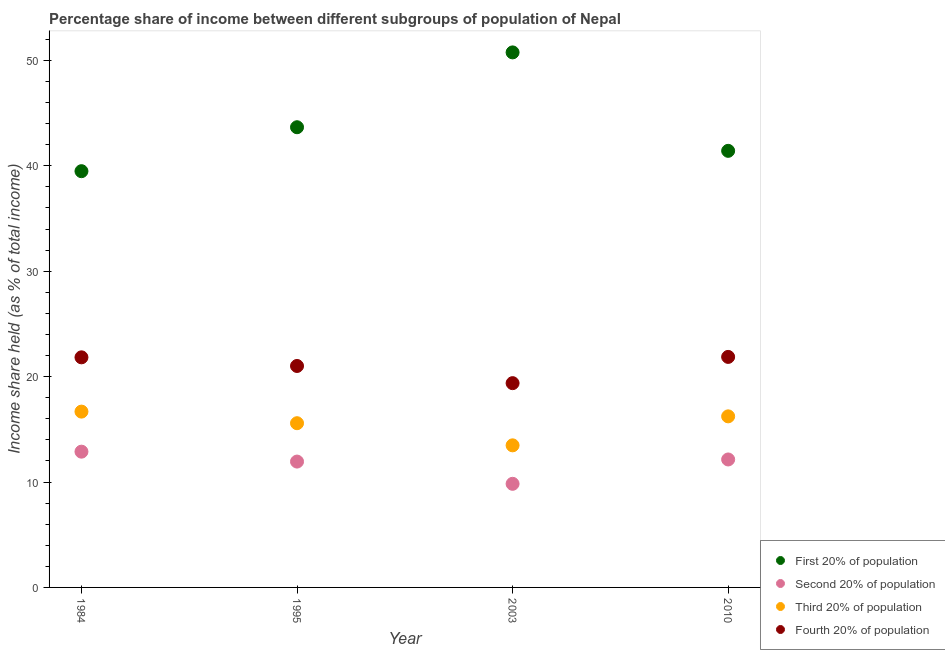How many different coloured dotlines are there?
Provide a succinct answer. 4. What is the share of the income held by fourth 20% of the population in 1995?
Offer a terse response. 21.01. Across all years, what is the maximum share of the income held by second 20% of the population?
Provide a short and direct response. 12.88. Across all years, what is the minimum share of the income held by first 20% of the population?
Ensure brevity in your answer.  39.49. In which year was the share of the income held by fourth 20% of the population minimum?
Offer a very short reply. 2003. What is the total share of the income held by fourth 20% of the population in the graph?
Your response must be concise. 84.09. What is the difference between the share of the income held by second 20% of the population in 1984 and that in 2003?
Keep it short and to the point. 3.05. What is the difference between the share of the income held by third 20% of the population in 2010 and the share of the income held by fourth 20% of the population in 1995?
Provide a short and direct response. -4.78. What is the average share of the income held by fourth 20% of the population per year?
Provide a succinct answer. 21.02. In the year 1984, what is the difference between the share of the income held by first 20% of the population and share of the income held by second 20% of the population?
Provide a succinct answer. 26.61. What is the ratio of the share of the income held by second 20% of the population in 1984 to that in 2003?
Provide a succinct answer. 1.31. Is the difference between the share of the income held by fourth 20% of the population in 1984 and 2003 greater than the difference between the share of the income held by third 20% of the population in 1984 and 2003?
Give a very brief answer. No. What is the difference between the highest and the second highest share of the income held by second 20% of the population?
Offer a very short reply. 0.74. What is the difference between the highest and the lowest share of the income held by second 20% of the population?
Provide a short and direct response. 3.05. Is it the case that in every year, the sum of the share of the income held by fourth 20% of the population and share of the income held by second 20% of the population is greater than the sum of share of the income held by first 20% of the population and share of the income held by third 20% of the population?
Offer a terse response. No. Does the share of the income held by third 20% of the population monotonically increase over the years?
Your answer should be compact. No. Is the share of the income held by first 20% of the population strictly greater than the share of the income held by fourth 20% of the population over the years?
Make the answer very short. Yes. Is the share of the income held by fourth 20% of the population strictly less than the share of the income held by third 20% of the population over the years?
Your answer should be very brief. No. How many years are there in the graph?
Make the answer very short. 4. Are the values on the major ticks of Y-axis written in scientific E-notation?
Provide a succinct answer. No. What is the title of the graph?
Your answer should be compact. Percentage share of income between different subgroups of population of Nepal. What is the label or title of the X-axis?
Provide a succinct answer. Year. What is the label or title of the Y-axis?
Your response must be concise. Income share held (as % of total income). What is the Income share held (as % of total income) of First 20% of population in 1984?
Your answer should be compact. 39.49. What is the Income share held (as % of total income) of Second 20% of population in 1984?
Make the answer very short. 12.88. What is the Income share held (as % of total income) in Third 20% of population in 1984?
Your answer should be very brief. 16.68. What is the Income share held (as % of total income) in Fourth 20% of population in 1984?
Provide a succinct answer. 21.83. What is the Income share held (as % of total income) in First 20% of population in 1995?
Give a very brief answer. 43.66. What is the Income share held (as % of total income) in Second 20% of population in 1995?
Your answer should be compact. 11.94. What is the Income share held (as % of total income) in Third 20% of population in 1995?
Your answer should be compact. 15.58. What is the Income share held (as % of total income) of Fourth 20% of population in 1995?
Make the answer very short. 21.01. What is the Income share held (as % of total income) in First 20% of population in 2003?
Offer a very short reply. 50.76. What is the Income share held (as % of total income) in Second 20% of population in 2003?
Provide a succinct answer. 9.83. What is the Income share held (as % of total income) of Third 20% of population in 2003?
Provide a short and direct response. 13.48. What is the Income share held (as % of total income) in Fourth 20% of population in 2003?
Give a very brief answer. 19.38. What is the Income share held (as % of total income) of First 20% of population in 2010?
Make the answer very short. 41.42. What is the Income share held (as % of total income) of Second 20% of population in 2010?
Provide a succinct answer. 12.14. What is the Income share held (as % of total income) of Third 20% of population in 2010?
Ensure brevity in your answer.  16.23. What is the Income share held (as % of total income) in Fourth 20% of population in 2010?
Offer a terse response. 21.87. Across all years, what is the maximum Income share held (as % of total income) of First 20% of population?
Provide a succinct answer. 50.76. Across all years, what is the maximum Income share held (as % of total income) in Second 20% of population?
Make the answer very short. 12.88. Across all years, what is the maximum Income share held (as % of total income) of Third 20% of population?
Offer a terse response. 16.68. Across all years, what is the maximum Income share held (as % of total income) of Fourth 20% of population?
Provide a short and direct response. 21.87. Across all years, what is the minimum Income share held (as % of total income) of First 20% of population?
Offer a very short reply. 39.49. Across all years, what is the minimum Income share held (as % of total income) in Second 20% of population?
Ensure brevity in your answer.  9.83. Across all years, what is the minimum Income share held (as % of total income) of Third 20% of population?
Ensure brevity in your answer.  13.48. Across all years, what is the minimum Income share held (as % of total income) of Fourth 20% of population?
Provide a succinct answer. 19.38. What is the total Income share held (as % of total income) of First 20% of population in the graph?
Make the answer very short. 175.33. What is the total Income share held (as % of total income) of Second 20% of population in the graph?
Make the answer very short. 46.79. What is the total Income share held (as % of total income) of Third 20% of population in the graph?
Give a very brief answer. 61.97. What is the total Income share held (as % of total income) in Fourth 20% of population in the graph?
Ensure brevity in your answer.  84.09. What is the difference between the Income share held (as % of total income) of First 20% of population in 1984 and that in 1995?
Provide a succinct answer. -4.17. What is the difference between the Income share held (as % of total income) in Second 20% of population in 1984 and that in 1995?
Make the answer very short. 0.94. What is the difference between the Income share held (as % of total income) in Fourth 20% of population in 1984 and that in 1995?
Your response must be concise. 0.82. What is the difference between the Income share held (as % of total income) of First 20% of population in 1984 and that in 2003?
Your answer should be very brief. -11.27. What is the difference between the Income share held (as % of total income) of Second 20% of population in 1984 and that in 2003?
Give a very brief answer. 3.05. What is the difference between the Income share held (as % of total income) of Third 20% of population in 1984 and that in 2003?
Give a very brief answer. 3.2. What is the difference between the Income share held (as % of total income) of Fourth 20% of population in 1984 and that in 2003?
Your answer should be compact. 2.45. What is the difference between the Income share held (as % of total income) of First 20% of population in 1984 and that in 2010?
Keep it short and to the point. -1.93. What is the difference between the Income share held (as % of total income) in Second 20% of population in 1984 and that in 2010?
Keep it short and to the point. 0.74. What is the difference between the Income share held (as % of total income) of Third 20% of population in 1984 and that in 2010?
Provide a succinct answer. 0.45. What is the difference between the Income share held (as % of total income) in Fourth 20% of population in 1984 and that in 2010?
Your answer should be compact. -0.04. What is the difference between the Income share held (as % of total income) in Second 20% of population in 1995 and that in 2003?
Keep it short and to the point. 2.11. What is the difference between the Income share held (as % of total income) in Fourth 20% of population in 1995 and that in 2003?
Offer a terse response. 1.63. What is the difference between the Income share held (as % of total income) of First 20% of population in 1995 and that in 2010?
Your answer should be compact. 2.24. What is the difference between the Income share held (as % of total income) of Third 20% of population in 1995 and that in 2010?
Offer a very short reply. -0.65. What is the difference between the Income share held (as % of total income) in Fourth 20% of population in 1995 and that in 2010?
Your answer should be very brief. -0.86. What is the difference between the Income share held (as % of total income) of First 20% of population in 2003 and that in 2010?
Keep it short and to the point. 9.34. What is the difference between the Income share held (as % of total income) in Second 20% of population in 2003 and that in 2010?
Keep it short and to the point. -2.31. What is the difference between the Income share held (as % of total income) of Third 20% of population in 2003 and that in 2010?
Offer a terse response. -2.75. What is the difference between the Income share held (as % of total income) in Fourth 20% of population in 2003 and that in 2010?
Provide a short and direct response. -2.49. What is the difference between the Income share held (as % of total income) of First 20% of population in 1984 and the Income share held (as % of total income) of Second 20% of population in 1995?
Provide a succinct answer. 27.55. What is the difference between the Income share held (as % of total income) in First 20% of population in 1984 and the Income share held (as % of total income) in Third 20% of population in 1995?
Your response must be concise. 23.91. What is the difference between the Income share held (as % of total income) of First 20% of population in 1984 and the Income share held (as % of total income) of Fourth 20% of population in 1995?
Ensure brevity in your answer.  18.48. What is the difference between the Income share held (as % of total income) of Second 20% of population in 1984 and the Income share held (as % of total income) of Fourth 20% of population in 1995?
Your response must be concise. -8.13. What is the difference between the Income share held (as % of total income) of Third 20% of population in 1984 and the Income share held (as % of total income) of Fourth 20% of population in 1995?
Your answer should be very brief. -4.33. What is the difference between the Income share held (as % of total income) in First 20% of population in 1984 and the Income share held (as % of total income) in Second 20% of population in 2003?
Your answer should be very brief. 29.66. What is the difference between the Income share held (as % of total income) of First 20% of population in 1984 and the Income share held (as % of total income) of Third 20% of population in 2003?
Offer a terse response. 26.01. What is the difference between the Income share held (as % of total income) in First 20% of population in 1984 and the Income share held (as % of total income) in Fourth 20% of population in 2003?
Your answer should be very brief. 20.11. What is the difference between the Income share held (as % of total income) in Second 20% of population in 1984 and the Income share held (as % of total income) in Third 20% of population in 2003?
Make the answer very short. -0.6. What is the difference between the Income share held (as % of total income) of Third 20% of population in 1984 and the Income share held (as % of total income) of Fourth 20% of population in 2003?
Keep it short and to the point. -2.7. What is the difference between the Income share held (as % of total income) of First 20% of population in 1984 and the Income share held (as % of total income) of Second 20% of population in 2010?
Provide a succinct answer. 27.35. What is the difference between the Income share held (as % of total income) of First 20% of population in 1984 and the Income share held (as % of total income) of Third 20% of population in 2010?
Your answer should be compact. 23.26. What is the difference between the Income share held (as % of total income) in First 20% of population in 1984 and the Income share held (as % of total income) in Fourth 20% of population in 2010?
Offer a very short reply. 17.62. What is the difference between the Income share held (as % of total income) of Second 20% of population in 1984 and the Income share held (as % of total income) of Third 20% of population in 2010?
Ensure brevity in your answer.  -3.35. What is the difference between the Income share held (as % of total income) of Second 20% of population in 1984 and the Income share held (as % of total income) of Fourth 20% of population in 2010?
Keep it short and to the point. -8.99. What is the difference between the Income share held (as % of total income) in Third 20% of population in 1984 and the Income share held (as % of total income) in Fourth 20% of population in 2010?
Ensure brevity in your answer.  -5.19. What is the difference between the Income share held (as % of total income) in First 20% of population in 1995 and the Income share held (as % of total income) in Second 20% of population in 2003?
Offer a terse response. 33.83. What is the difference between the Income share held (as % of total income) of First 20% of population in 1995 and the Income share held (as % of total income) of Third 20% of population in 2003?
Give a very brief answer. 30.18. What is the difference between the Income share held (as % of total income) in First 20% of population in 1995 and the Income share held (as % of total income) in Fourth 20% of population in 2003?
Your answer should be very brief. 24.28. What is the difference between the Income share held (as % of total income) of Second 20% of population in 1995 and the Income share held (as % of total income) of Third 20% of population in 2003?
Your answer should be compact. -1.54. What is the difference between the Income share held (as % of total income) of Second 20% of population in 1995 and the Income share held (as % of total income) of Fourth 20% of population in 2003?
Keep it short and to the point. -7.44. What is the difference between the Income share held (as % of total income) of First 20% of population in 1995 and the Income share held (as % of total income) of Second 20% of population in 2010?
Provide a succinct answer. 31.52. What is the difference between the Income share held (as % of total income) of First 20% of population in 1995 and the Income share held (as % of total income) of Third 20% of population in 2010?
Your answer should be very brief. 27.43. What is the difference between the Income share held (as % of total income) in First 20% of population in 1995 and the Income share held (as % of total income) in Fourth 20% of population in 2010?
Provide a short and direct response. 21.79. What is the difference between the Income share held (as % of total income) in Second 20% of population in 1995 and the Income share held (as % of total income) in Third 20% of population in 2010?
Provide a succinct answer. -4.29. What is the difference between the Income share held (as % of total income) of Second 20% of population in 1995 and the Income share held (as % of total income) of Fourth 20% of population in 2010?
Provide a succinct answer. -9.93. What is the difference between the Income share held (as % of total income) in Third 20% of population in 1995 and the Income share held (as % of total income) in Fourth 20% of population in 2010?
Keep it short and to the point. -6.29. What is the difference between the Income share held (as % of total income) of First 20% of population in 2003 and the Income share held (as % of total income) of Second 20% of population in 2010?
Your response must be concise. 38.62. What is the difference between the Income share held (as % of total income) in First 20% of population in 2003 and the Income share held (as % of total income) in Third 20% of population in 2010?
Your response must be concise. 34.53. What is the difference between the Income share held (as % of total income) of First 20% of population in 2003 and the Income share held (as % of total income) of Fourth 20% of population in 2010?
Your answer should be compact. 28.89. What is the difference between the Income share held (as % of total income) in Second 20% of population in 2003 and the Income share held (as % of total income) in Third 20% of population in 2010?
Your answer should be very brief. -6.4. What is the difference between the Income share held (as % of total income) of Second 20% of population in 2003 and the Income share held (as % of total income) of Fourth 20% of population in 2010?
Make the answer very short. -12.04. What is the difference between the Income share held (as % of total income) of Third 20% of population in 2003 and the Income share held (as % of total income) of Fourth 20% of population in 2010?
Offer a terse response. -8.39. What is the average Income share held (as % of total income) in First 20% of population per year?
Keep it short and to the point. 43.83. What is the average Income share held (as % of total income) in Second 20% of population per year?
Provide a short and direct response. 11.7. What is the average Income share held (as % of total income) of Third 20% of population per year?
Give a very brief answer. 15.49. What is the average Income share held (as % of total income) in Fourth 20% of population per year?
Your answer should be very brief. 21.02. In the year 1984, what is the difference between the Income share held (as % of total income) in First 20% of population and Income share held (as % of total income) in Second 20% of population?
Your response must be concise. 26.61. In the year 1984, what is the difference between the Income share held (as % of total income) of First 20% of population and Income share held (as % of total income) of Third 20% of population?
Give a very brief answer. 22.81. In the year 1984, what is the difference between the Income share held (as % of total income) in First 20% of population and Income share held (as % of total income) in Fourth 20% of population?
Provide a succinct answer. 17.66. In the year 1984, what is the difference between the Income share held (as % of total income) of Second 20% of population and Income share held (as % of total income) of Fourth 20% of population?
Offer a terse response. -8.95. In the year 1984, what is the difference between the Income share held (as % of total income) of Third 20% of population and Income share held (as % of total income) of Fourth 20% of population?
Your response must be concise. -5.15. In the year 1995, what is the difference between the Income share held (as % of total income) in First 20% of population and Income share held (as % of total income) in Second 20% of population?
Provide a succinct answer. 31.72. In the year 1995, what is the difference between the Income share held (as % of total income) of First 20% of population and Income share held (as % of total income) of Third 20% of population?
Your response must be concise. 28.08. In the year 1995, what is the difference between the Income share held (as % of total income) in First 20% of population and Income share held (as % of total income) in Fourth 20% of population?
Your response must be concise. 22.65. In the year 1995, what is the difference between the Income share held (as % of total income) of Second 20% of population and Income share held (as % of total income) of Third 20% of population?
Offer a very short reply. -3.64. In the year 1995, what is the difference between the Income share held (as % of total income) of Second 20% of population and Income share held (as % of total income) of Fourth 20% of population?
Provide a short and direct response. -9.07. In the year 1995, what is the difference between the Income share held (as % of total income) of Third 20% of population and Income share held (as % of total income) of Fourth 20% of population?
Provide a short and direct response. -5.43. In the year 2003, what is the difference between the Income share held (as % of total income) in First 20% of population and Income share held (as % of total income) in Second 20% of population?
Make the answer very short. 40.93. In the year 2003, what is the difference between the Income share held (as % of total income) of First 20% of population and Income share held (as % of total income) of Third 20% of population?
Your answer should be very brief. 37.28. In the year 2003, what is the difference between the Income share held (as % of total income) of First 20% of population and Income share held (as % of total income) of Fourth 20% of population?
Make the answer very short. 31.38. In the year 2003, what is the difference between the Income share held (as % of total income) in Second 20% of population and Income share held (as % of total income) in Third 20% of population?
Ensure brevity in your answer.  -3.65. In the year 2003, what is the difference between the Income share held (as % of total income) of Second 20% of population and Income share held (as % of total income) of Fourth 20% of population?
Make the answer very short. -9.55. In the year 2003, what is the difference between the Income share held (as % of total income) of Third 20% of population and Income share held (as % of total income) of Fourth 20% of population?
Offer a very short reply. -5.9. In the year 2010, what is the difference between the Income share held (as % of total income) in First 20% of population and Income share held (as % of total income) in Second 20% of population?
Your answer should be compact. 29.28. In the year 2010, what is the difference between the Income share held (as % of total income) in First 20% of population and Income share held (as % of total income) in Third 20% of population?
Your answer should be compact. 25.19. In the year 2010, what is the difference between the Income share held (as % of total income) of First 20% of population and Income share held (as % of total income) of Fourth 20% of population?
Offer a very short reply. 19.55. In the year 2010, what is the difference between the Income share held (as % of total income) in Second 20% of population and Income share held (as % of total income) in Third 20% of population?
Your answer should be compact. -4.09. In the year 2010, what is the difference between the Income share held (as % of total income) in Second 20% of population and Income share held (as % of total income) in Fourth 20% of population?
Your answer should be compact. -9.73. In the year 2010, what is the difference between the Income share held (as % of total income) in Third 20% of population and Income share held (as % of total income) in Fourth 20% of population?
Provide a short and direct response. -5.64. What is the ratio of the Income share held (as % of total income) in First 20% of population in 1984 to that in 1995?
Keep it short and to the point. 0.9. What is the ratio of the Income share held (as % of total income) of Second 20% of population in 1984 to that in 1995?
Give a very brief answer. 1.08. What is the ratio of the Income share held (as % of total income) in Third 20% of population in 1984 to that in 1995?
Keep it short and to the point. 1.07. What is the ratio of the Income share held (as % of total income) in Fourth 20% of population in 1984 to that in 1995?
Ensure brevity in your answer.  1.04. What is the ratio of the Income share held (as % of total income) of First 20% of population in 1984 to that in 2003?
Make the answer very short. 0.78. What is the ratio of the Income share held (as % of total income) of Second 20% of population in 1984 to that in 2003?
Provide a short and direct response. 1.31. What is the ratio of the Income share held (as % of total income) of Third 20% of population in 1984 to that in 2003?
Your answer should be very brief. 1.24. What is the ratio of the Income share held (as % of total income) of Fourth 20% of population in 1984 to that in 2003?
Your response must be concise. 1.13. What is the ratio of the Income share held (as % of total income) in First 20% of population in 1984 to that in 2010?
Your answer should be very brief. 0.95. What is the ratio of the Income share held (as % of total income) of Second 20% of population in 1984 to that in 2010?
Offer a very short reply. 1.06. What is the ratio of the Income share held (as % of total income) in Third 20% of population in 1984 to that in 2010?
Your response must be concise. 1.03. What is the ratio of the Income share held (as % of total income) of First 20% of population in 1995 to that in 2003?
Your answer should be very brief. 0.86. What is the ratio of the Income share held (as % of total income) of Second 20% of population in 1995 to that in 2003?
Offer a very short reply. 1.21. What is the ratio of the Income share held (as % of total income) in Third 20% of population in 1995 to that in 2003?
Provide a short and direct response. 1.16. What is the ratio of the Income share held (as % of total income) in Fourth 20% of population in 1995 to that in 2003?
Your answer should be compact. 1.08. What is the ratio of the Income share held (as % of total income) in First 20% of population in 1995 to that in 2010?
Your response must be concise. 1.05. What is the ratio of the Income share held (as % of total income) in Second 20% of population in 1995 to that in 2010?
Offer a very short reply. 0.98. What is the ratio of the Income share held (as % of total income) in Third 20% of population in 1995 to that in 2010?
Provide a short and direct response. 0.96. What is the ratio of the Income share held (as % of total income) in Fourth 20% of population in 1995 to that in 2010?
Keep it short and to the point. 0.96. What is the ratio of the Income share held (as % of total income) in First 20% of population in 2003 to that in 2010?
Your answer should be compact. 1.23. What is the ratio of the Income share held (as % of total income) in Second 20% of population in 2003 to that in 2010?
Provide a short and direct response. 0.81. What is the ratio of the Income share held (as % of total income) of Third 20% of population in 2003 to that in 2010?
Give a very brief answer. 0.83. What is the ratio of the Income share held (as % of total income) of Fourth 20% of population in 2003 to that in 2010?
Provide a succinct answer. 0.89. What is the difference between the highest and the second highest Income share held (as % of total income) in First 20% of population?
Make the answer very short. 7.1. What is the difference between the highest and the second highest Income share held (as % of total income) in Second 20% of population?
Provide a succinct answer. 0.74. What is the difference between the highest and the second highest Income share held (as % of total income) of Third 20% of population?
Keep it short and to the point. 0.45. What is the difference between the highest and the lowest Income share held (as % of total income) in First 20% of population?
Your answer should be compact. 11.27. What is the difference between the highest and the lowest Income share held (as % of total income) of Second 20% of population?
Your response must be concise. 3.05. What is the difference between the highest and the lowest Income share held (as % of total income) in Third 20% of population?
Provide a succinct answer. 3.2. What is the difference between the highest and the lowest Income share held (as % of total income) in Fourth 20% of population?
Keep it short and to the point. 2.49. 